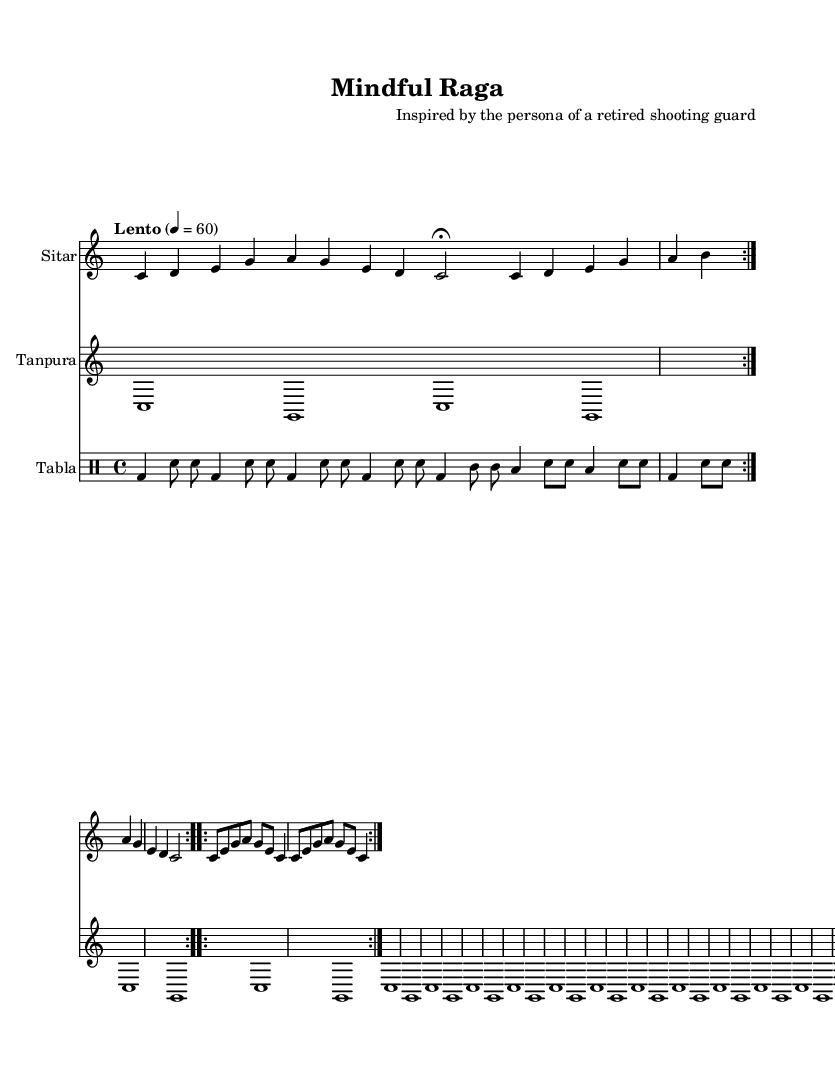What is the key signature of this music? The key signature indicated is C major, which is typically represented by no sharps or flats on the staff.
Answer: C major What is the time signature of this music? The time signature shown is 4/4, indicating four beats per measure, with each beat represented by a quarter note.
Answer: 4/4 What is the tempo marking of this piece? The tempo marking states "Lento," which generally means a slow tempo, and it is set at a specific speed of 60 beats per minute.
Answer: Lento, 60 How many times is the Jhala section repeated? In the score, the Jhala section is indicated to be repeated twice, as denoted by the "volta 2" instruction.
Answer: 2 What is the primary instrument featured in the score? The primary instrument featured as per the notation at the beginning of the score is the "Sitar," which is commonly associated with Indian classical music.
Answer: Sitar What type of percussive instrument is used in this music? The music features the "Tabla," which is a traditional Indian percussion instrument composed of two hand-played drums.
Answer: Tabla What is the overall structure of this composition? The composition has a structure that follows three segments: Alap, Jor, and Jhala, which are typical in a raga performance.
Answer: Alap, Jor, Jhala 